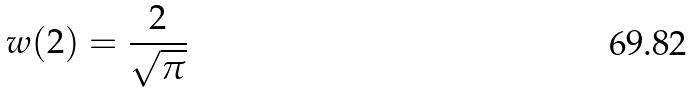Convert formula to latex. <formula><loc_0><loc_0><loc_500><loc_500>w ( 2 ) = \frac { 2 } { \sqrt { \pi } }</formula> 